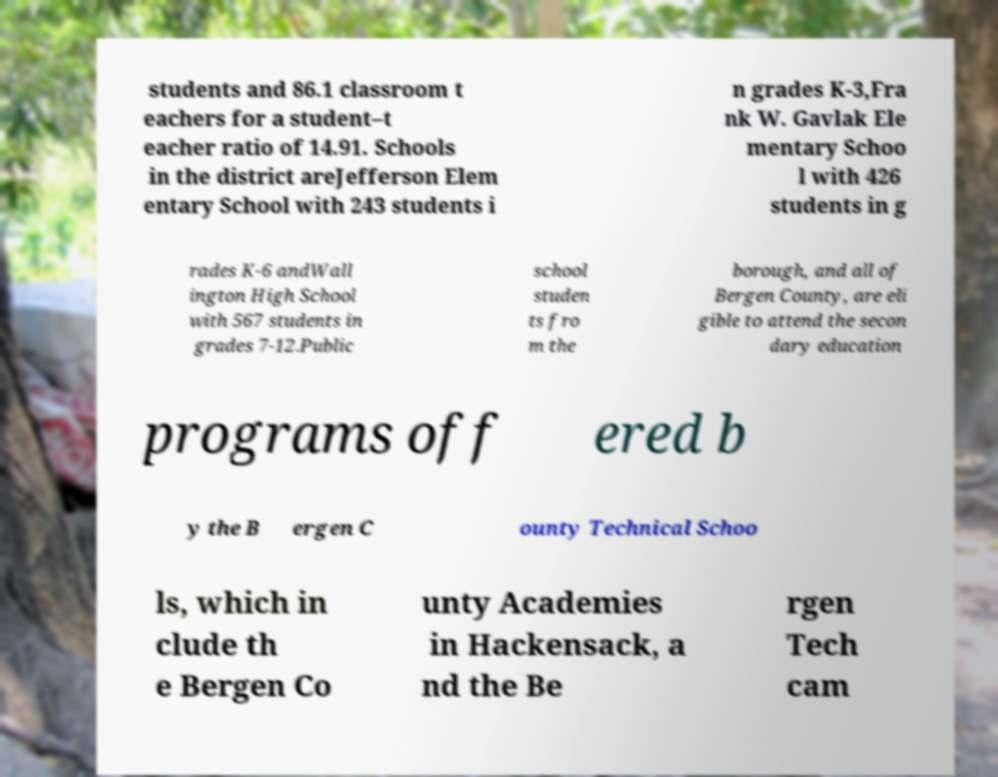I need the written content from this picture converted into text. Can you do that? students and 86.1 classroom t eachers for a student–t eacher ratio of 14.91. Schools in the district areJefferson Elem entary School with 243 students i n grades K-3,Fra nk W. Gavlak Ele mentary Schoo l with 426 students in g rades K-6 andWall ington High School with 567 students in grades 7-12.Public school studen ts fro m the borough, and all of Bergen County, are eli gible to attend the secon dary education programs off ered b y the B ergen C ounty Technical Schoo ls, which in clude th e Bergen Co unty Academies in Hackensack, a nd the Be rgen Tech cam 